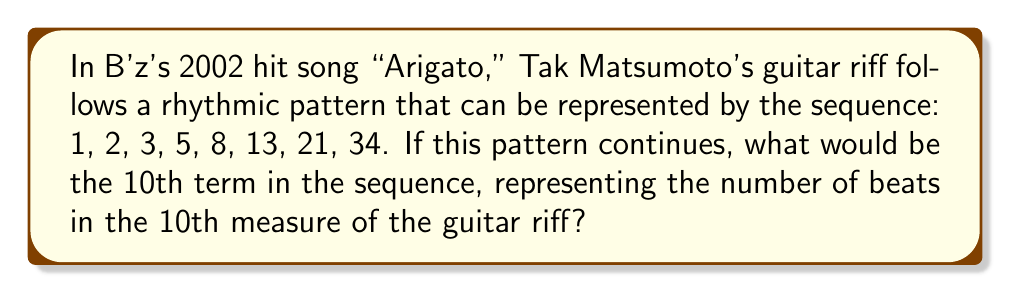Give your solution to this math problem. To solve this problem, let's analyze the given sequence:

1. Observe the pattern: 1, 2, 3, 5, 8, 13, 21, 34

2. Recognize that this is a Fibonacci sequence, where each term is the sum of the two preceding terms.

3. Let's continue the sequence for two more terms:
   - 9th term: $34 + 21 = 55$
   - 10th term: $55 + 34 = 89$

4. We can express this mathematically as:

   $$F_n = F_{n-1} + F_{n-2}$$

   Where $F_n$ represents the nth term in the Fibonacci sequence.

5. For the 10th term:
   
   $$F_{10} = F_9 + F_8 = 55 + 34 = 89$$

Therefore, the 10th term in the sequence, representing the number of beats in the 10th measure of Tak Matsumoto's guitar riff, would be 89.
Answer: 89 